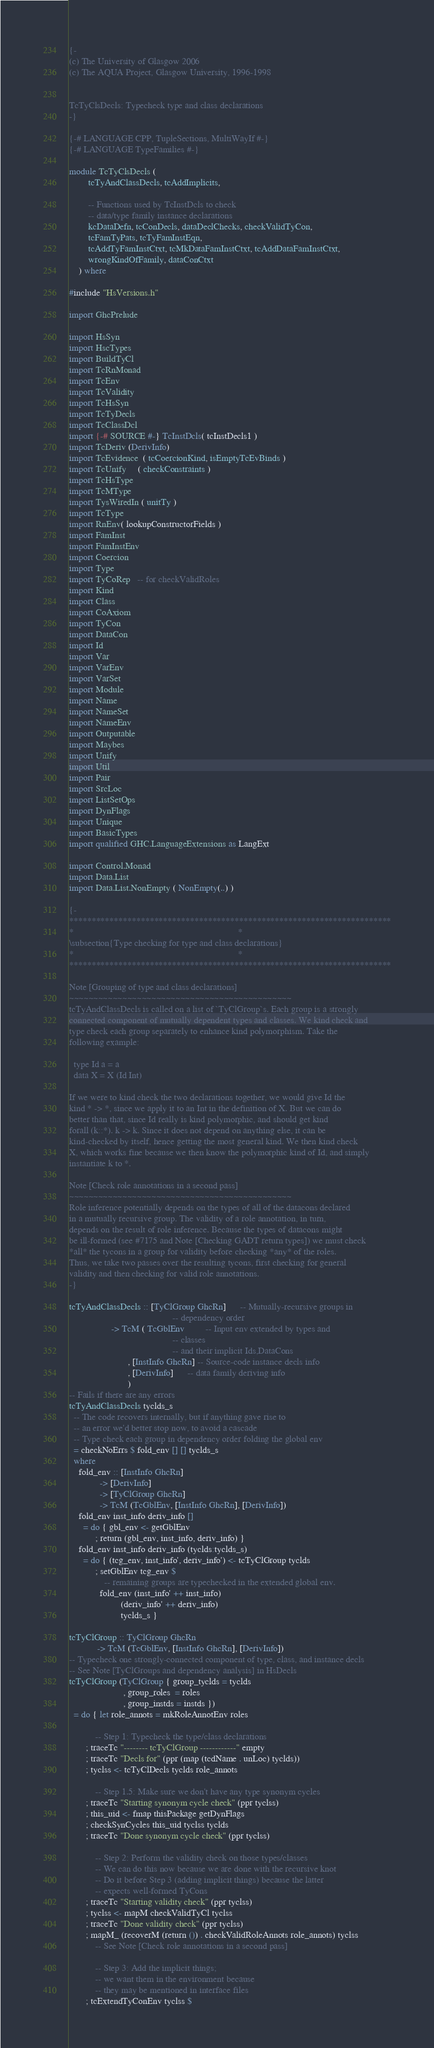Convert code to text. <code><loc_0><loc_0><loc_500><loc_500><_Haskell_>{-
(c) The University of Glasgow 2006
(c) The AQUA Project, Glasgow University, 1996-1998


TcTyClsDecls: Typecheck type and class declarations
-}

{-# LANGUAGE CPP, TupleSections, MultiWayIf #-}
{-# LANGUAGE TypeFamilies #-}

module TcTyClsDecls (
        tcTyAndClassDecls, tcAddImplicits,

        -- Functions used by TcInstDcls to check
        -- data/type family instance declarations
        kcDataDefn, tcConDecls, dataDeclChecks, checkValidTyCon,
        tcFamTyPats, tcTyFamInstEqn,
        tcAddTyFamInstCtxt, tcMkDataFamInstCtxt, tcAddDataFamInstCtxt,
        wrongKindOfFamily, dataConCtxt
    ) where

#include "HsVersions.h"

import GhcPrelude

import HsSyn
import HscTypes
import BuildTyCl
import TcRnMonad
import TcEnv
import TcValidity
import TcHsSyn
import TcTyDecls
import TcClassDcl
import {-# SOURCE #-} TcInstDcls( tcInstDecls1 )
import TcDeriv (DerivInfo)
import TcEvidence  ( tcCoercionKind, isEmptyTcEvBinds )
import TcUnify     ( checkConstraints )
import TcHsType
import TcMType
import TysWiredIn ( unitTy )
import TcType
import RnEnv( lookupConstructorFields )
import FamInst
import FamInstEnv
import Coercion
import Type
import TyCoRep   -- for checkValidRoles
import Kind
import Class
import CoAxiom
import TyCon
import DataCon
import Id
import Var
import VarEnv
import VarSet
import Module
import Name
import NameSet
import NameEnv
import Outputable
import Maybes
import Unify
import Util
import Pair
import SrcLoc
import ListSetOps
import DynFlags
import Unique
import BasicTypes
import qualified GHC.LanguageExtensions as LangExt

import Control.Monad
import Data.List
import Data.List.NonEmpty ( NonEmpty(..) )

{-
************************************************************************
*                                                                      *
\subsection{Type checking for type and class declarations}
*                                                                      *
************************************************************************

Note [Grouping of type and class declarations]
~~~~~~~~~~~~~~~~~~~~~~~~~~~~~~~~~~~~~~~~~~~~~~
tcTyAndClassDecls is called on a list of `TyClGroup`s. Each group is a strongly
connected component of mutually dependent types and classes. We kind check and
type check each group separately to enhance kind polymorphism. Take the
following example:

  type Id a = a
  data X = X (Id Int)

If we were to kind check the two declarations together, we would give Id the
kind * -> *, since we apply it to an Int in the definition of X. But we can do
better than that, since Id really is kind polymorphic, and should get kind
forall (k::*). k -> k. Since it does not depend on anything else, it can be
kind-checked by itself, hence getting the most general kind. We then kind check
X, which works fine because we then know the polymorphic kind of Id, and simply
instantiate k to *.

Note [Check role annotations in a second pass]
~~~~~~~~~~~~~~~~~~~~~~~~~~~~~~~~~~~~~~~~~~~~~~
Role inference potentially depends on the types of all of the datacons declared
in a mutually recursive group. The validity of a role annotation, in turn,
depends on the result of role inference. Because the types of datacons might
be ill-formed (see #7175 and Note [Checking GADT return types]) we must check
*all* the tycons in a group for validity before checking *any* of the roles.
Thus, we take two passes over the resulting tycons, first checking for general
validity and then checking for valid role annotations.
-}

tcTyAndClassDecls :: [TyClGroup GhcRn]      -- Mutually-recursive groups in
                                            -- dependency order
                  -> TcM ( TcGblEnv         -- Input env extended by types and
                                            -- classes
                                            -- and their implicit Ids,DataCons
                         , [InstInfo GhcRn] -- Source-code instance decls info
                         , [DerivInfo]      -- data family deriving info
                         )
-- Fails if there are any errors
tcTyAndClassDecls tyclds_s
  -- The code recovers internally, but if anything gave rise to
  -- an error we'd better stop now, to avoid a cascade
  -- Type check each group in dependency order folding the global env
  = checkNoErrs $ fold_env [] [] tyclds_s
  where
    fold_env :: [InstInfo GhcRn]
             -> [DerivInfo]
             -> [TyClGroup GhcRn]
             -> TcM (TcGblEnv, [InstInfo GhcRn], [DerivInfo])
    fold_env inst_info deriv_info []
      = do { gbl_env <- getGblEnv
           ; return (gbl_env, inst_info, deriv_info) }
    fold_env inst_info deriv_info (tyclds:tyclds_s)
      = do { (tcg_env, inst_info', deriv_info') <- tcTyClGroup tyclds
           ; setGblEnv tcg_env $
               -- remaining groups are typechecked in the extended global env.
             fold_env (inst_info' ++ inst_info)
                      (deriv_info' ++ deriv_info)
                      tyclds_s }

tcTyClGroup :: TyClGroup GhcRn
            -> TcM (TcGblEnv, [InstInfo GhcRn], [DerivInfo])
-- Typecheck one strongly-connected component of type, class, and instance decls
-- See Note [TyClGroups and dependency analysis] in HsDecls
tcTyClGroup (TyClGroup { group_tyclds = tyclds
                       , group_roles  = roles
                       , group_instds = instds })
  = do { let role_annots = mkRoleAnnotEnv roles

           -- Step 1: Typecheck the type/class declarations
       ; traceTc "-------- tcTyClGroup ------------" empty
       ; traceTc "Decls for" (ppr (map (tcdName . unLoc) tyclds))
       ; tyclss <- tcTyClDecls tyclds role_annots

           -- Step 1.5: Make sure we don't have any type synonym cycles
       ; traceTc "Starting synonym cycle check" (ppr tyclss)
       ; this_uid <- fmap thisPackage getDynFlags
       ; checkSynCycles this_uid tyclss tyclds
       ; traceTc "Done synonym cycle check" (ppr tyclss)

           -- Step 2: Perform the validity check on those types/classes
           -- We can do this now because we are done with the recursive knot
           -- Do it before Step 3 (adding implicit things) because the latter
           -- expects well-formed TyCons
       ; traceTc "Starting validity check" (ppr tyclss)
       ; tyclss <- mapM checkValidTyCl tyclss
       ; traceTc "Done validity check" (ppr tyclss)
       ; mapM_ (recoverM (return ()) . checkValidRoleAnnots role_annots) tyclss
           -- See Note [Check role annotations in a second pass]

           -- Step 3: Add the implicit things;
           -- we want them in the environment because
           -- they may be mentioned in interface files
       ; tcExtendTyConEnv tyclss $</code> 